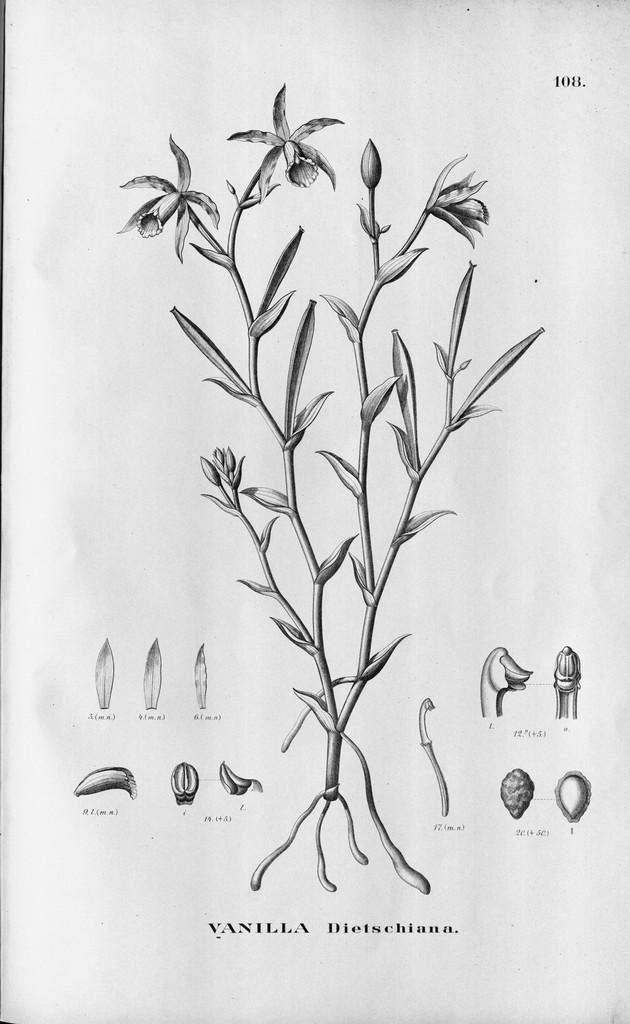What is the main object in the image? There is a printed paper in the image. Are there any living organisms in the image? Yes, there is a plant in the image. What can be found at the bottom of the image? There is text at the bottom of the image. Where is the number located in the image? The number is in the top right corner of the image. How many tomatoes are hanging from the plant in the image? There are no tomatoes present in the image; it only features a plant. What type of pets can be seen playing with the number in the image? There are no pets present in the image, and the number is not an object that can be played with. 